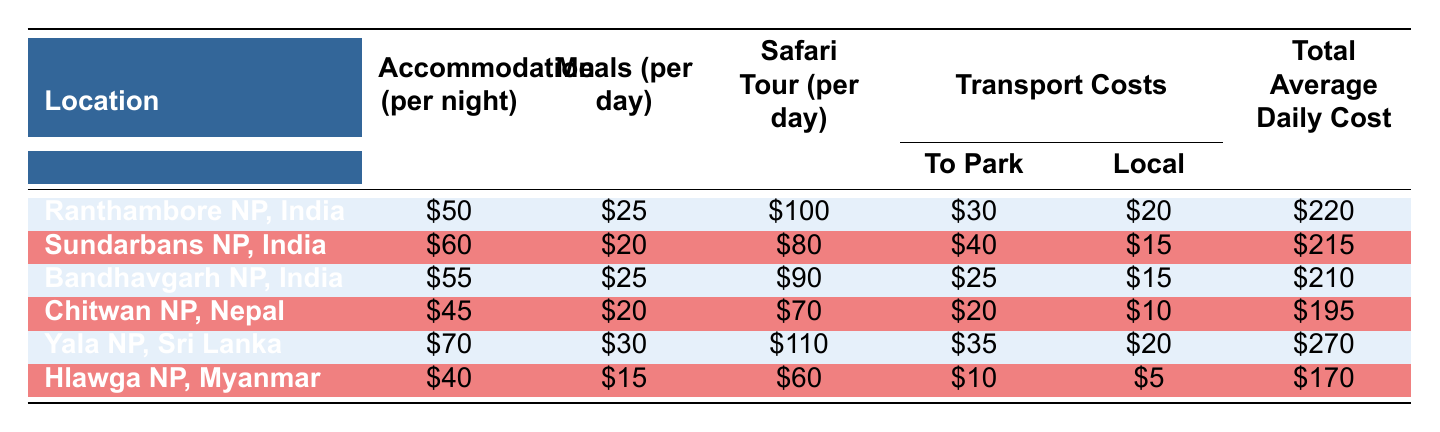What is the total average daily cost at Yala National Park, Sri Lanka? The table shows specific costs for each location, and for Yala National Park, it is listed as \$270 in the last column.
Answer: 270 Which location has the highest accommodation cost per night? By comparing the accommodation costs listed for each location, Yala National Park has the highest cost at \$70 per night.
Answer: Yala National Park, Sri Lanka Is the visa fee for Chitwan National Park higher than for Hlawga National Park? The visa fee for Chitwan National Park is \$30 and for Hlawga National Park it is \$40. Since \$30 is less than \$40, the statement is false.
Answer: No What is the difference in total average daily cost between Bandhavgarh National Park and Chitwan National Park? The total average daily costs are \$210 for Bandhavgarh and \$195 for Chitwan. The difference is \$210 - \$195 = \$15.
Answer: 15 If you visit Sundarbans National Park for three days, how much would you typically spend on meals alone? Sundarbans has meals costing \$20 per day. For three days, it would be \$20 * 3 = \$60.
Answer: 60 Which location has the lowest total average daily cost? By examining the total average daily costs, Hlawga National Park has the lowest cost at \$170, which is the smallest value in the last column.
Answer: Hlawga National Park, Myanmar What is the total transport cost (to the park and local) for visiting Ranthambore National Park in India? The transport costs to the park is \$30 and local transfers is \$20 for Ranthambore. The total is \$30 + \$20 = \$50.
Answer: 50 Which two locations have an average daily cost of less than \$200? Looking through the totals, Chitwan National Park at \$195 and Hlawga National Park at \$170 are both below \$200.
Answer: Chitwan National Park, Hlawga National Park Is the accommodation cost per night higher in Sundarbans National Park than in Bandhavgarh National Park? The accommodation cost for Sundarbans is \$60 and for Bandhavgarh is \$55. Since \$60 is greater than \$55, the statement is true.
Answer: Yes 